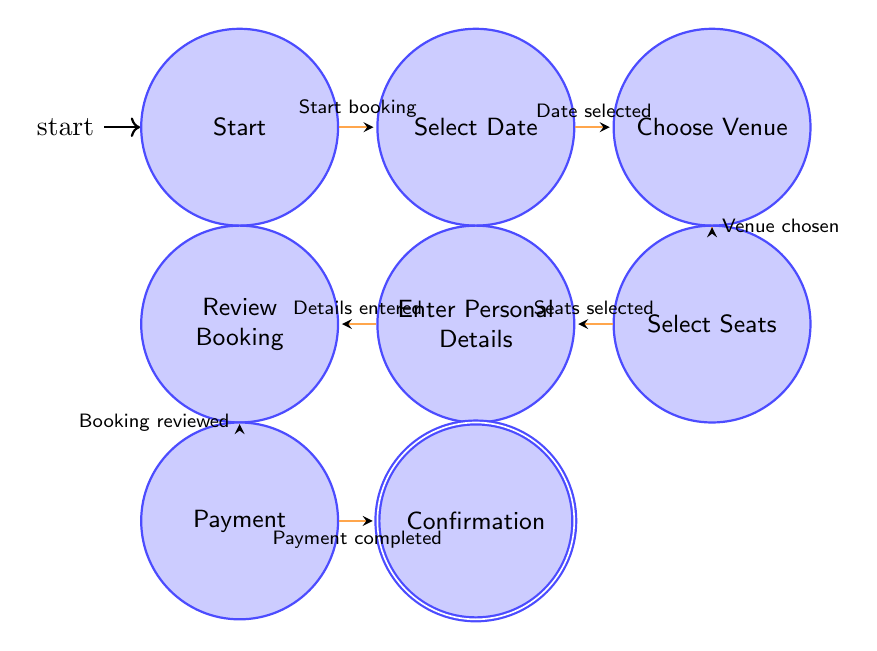What is the initial state in the diagram? The initial state is labeled "Start," where the ticket reservation process begins. This is indicated in the diagram with the state positioned at the far left and marked as the starting node.
Answer: Start How many states are there in total? By counting each of the individual states listed in the "states" section, there are a total of eight different states represented in the diagram.
Answer: Eight Which state follows "Select Date"? After "Select Date," the next state is "Choose Venue." The diagram shows this transition clearly, connecting the two states in a linear flow.
Answer: Choose Venue What action takes place after "Payment"? The action that occurs after "Payment" is "Confirmation." This transition indicates the completion of the ticket reservation process, leading to ticket issuance.
Answer: Confirmation What is the last step in the ticket reservation process? The last step, following all previous states, culminates in the state "Confirmation," which signifies that the user has successfully reserved a ticket.
Answer: Confirmation Which state does "Enter Personal Details" come before? "Enter Personal Details" comes before "Review Booking." In the diagram, there is a direct transition from the personal details state to the review state, indicating the flow of steps.
Answer: Review Booking What do users enter in the state "Enter Personal Details"? In "Enter Personal Details," users are required to input their name, email, and phone number, as indicated by the state description.
Answer: Personal details Is "Choose Venue" the first state in the process? No, "Choose Venue" is not the first state; it follows "Select Date." The diagram shows the order of operations starting from "Start" to "Select Date" and then to "Choose Venue."
Answer: No 